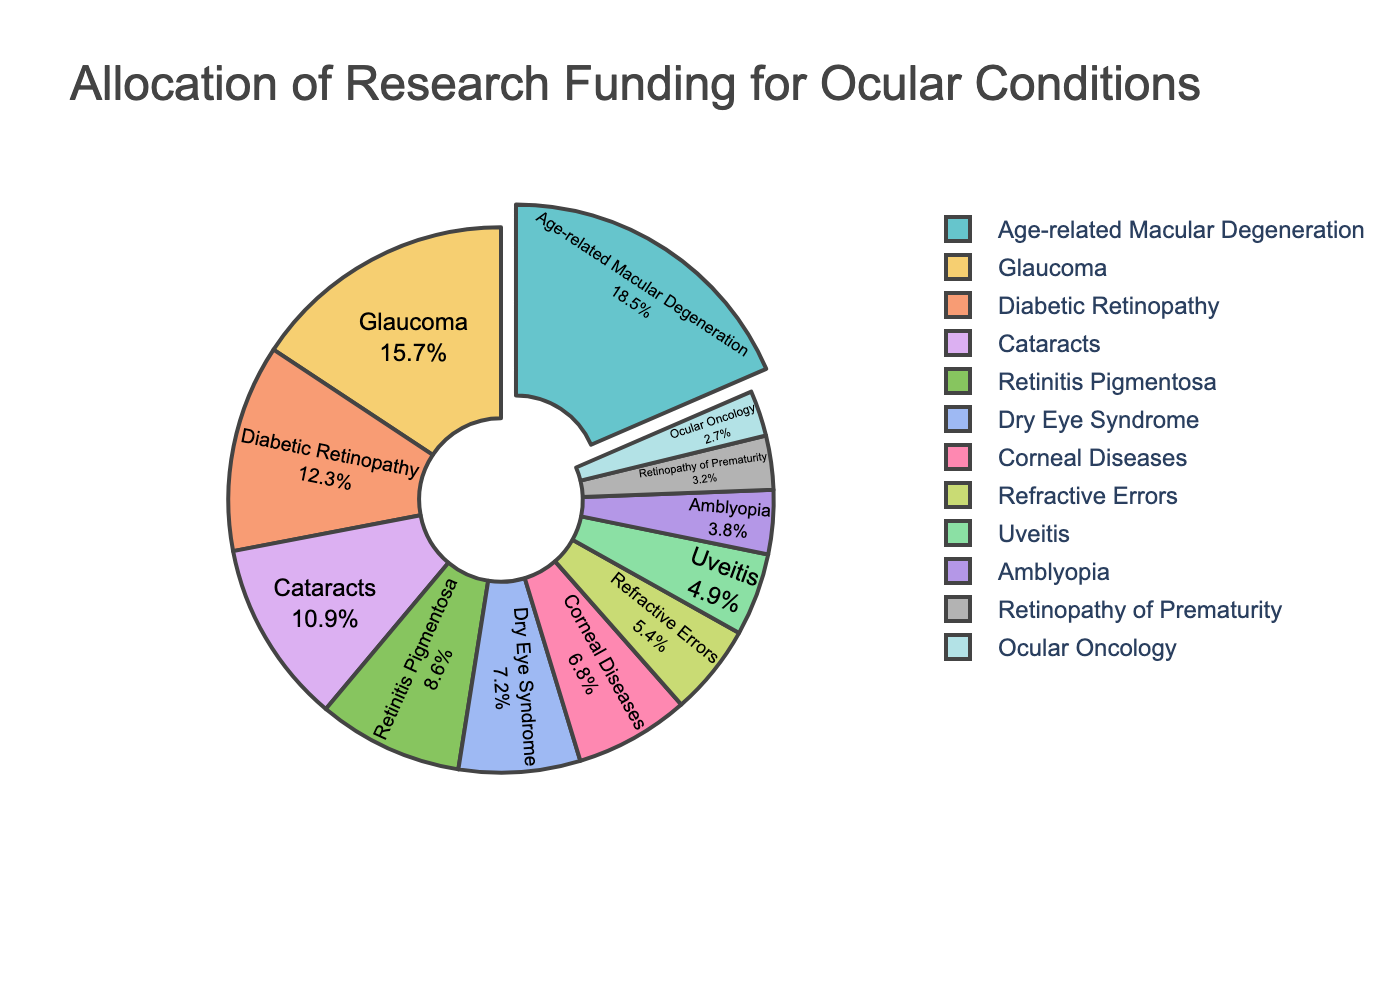Which ocular condition has the highest percentage allocation of research funding? The pie chart shows the percentages for each ocular condition. Age-related Macular Degeneration has the highest percentage allocation.
Answer: Age-related Macular Degeneration What is the combined funding percentage for Glaucoma and Diabetic Retinopathy? To find the combined percentage, add the individual percentages for Glaucoma (15.7%) and Diabetic Retinopathy (12.3%). 15.7% + 12.3% = 28.0%.
Answer: 28.0% Is the funding for Cataracts greater than the funding for Retinitis Pigmentosa? Compare the funding percentages for Cataracts (10.9%) and Retinitis Pigmentosa (8.6%). 10.9% is greater than 8.6%.
Answer: Yes Which condition receives the least research funding, and what is its percentage? The pie chart shows the funding percentages for each condition. Ocular Oncology receives the least funding at 2.7%.
Answer: Ocular Oncology, 2.7% How much more funding does Dry Eye Syndrome receive compared to Uveitis? Subtract the percentage for Uveitis from that of Dry Eye Syndrome (7.2% - 4.9%). 7.2% - 4.9% = 2.3%.
Answer: 2.3% What is the total funding percentage allocated to conditions other than Age-related Macular Degeneration? Subtract the percentage for Age-related Macular Degeneration from 100% (100% - 18.5%). 100% - 18.5% = 81.5%.
Answer: 81.5% Is the funding for Retinopathy of Prematurity less than half of the funding for Diabetic Retinopathy? Compare half of Diabetic Retinopathy funding (12.3% / 2 = 6.15%) to Retinopathy of Prematurity (3.2%). 3.2% is less than 6.15%.
Answer: Yes Are there any conditions that receive an equal amount of funding? The pie chart shows distinct percentages for each condition, so no two conditions receive the same funding.
Answer: No Which condition is allocated slightly more funding, Corneal Diseases or Refractive Errors? Compare the funding percentages for Corneal Diseases (6.8%) and Refractive Errors (5.4%). Corneal Diseases receive slightly more funding.
Answer: Corneal Diseases What is the difference in funding percentage between Amblyopia and Retinopathy of Prematurity? Subtract the percentage for Retinopathy of Prematurity from that of Amblyopia (3.8% - 3.2%). 3.8% - 3.2% = 0.6%.
Answer: 0.6% 